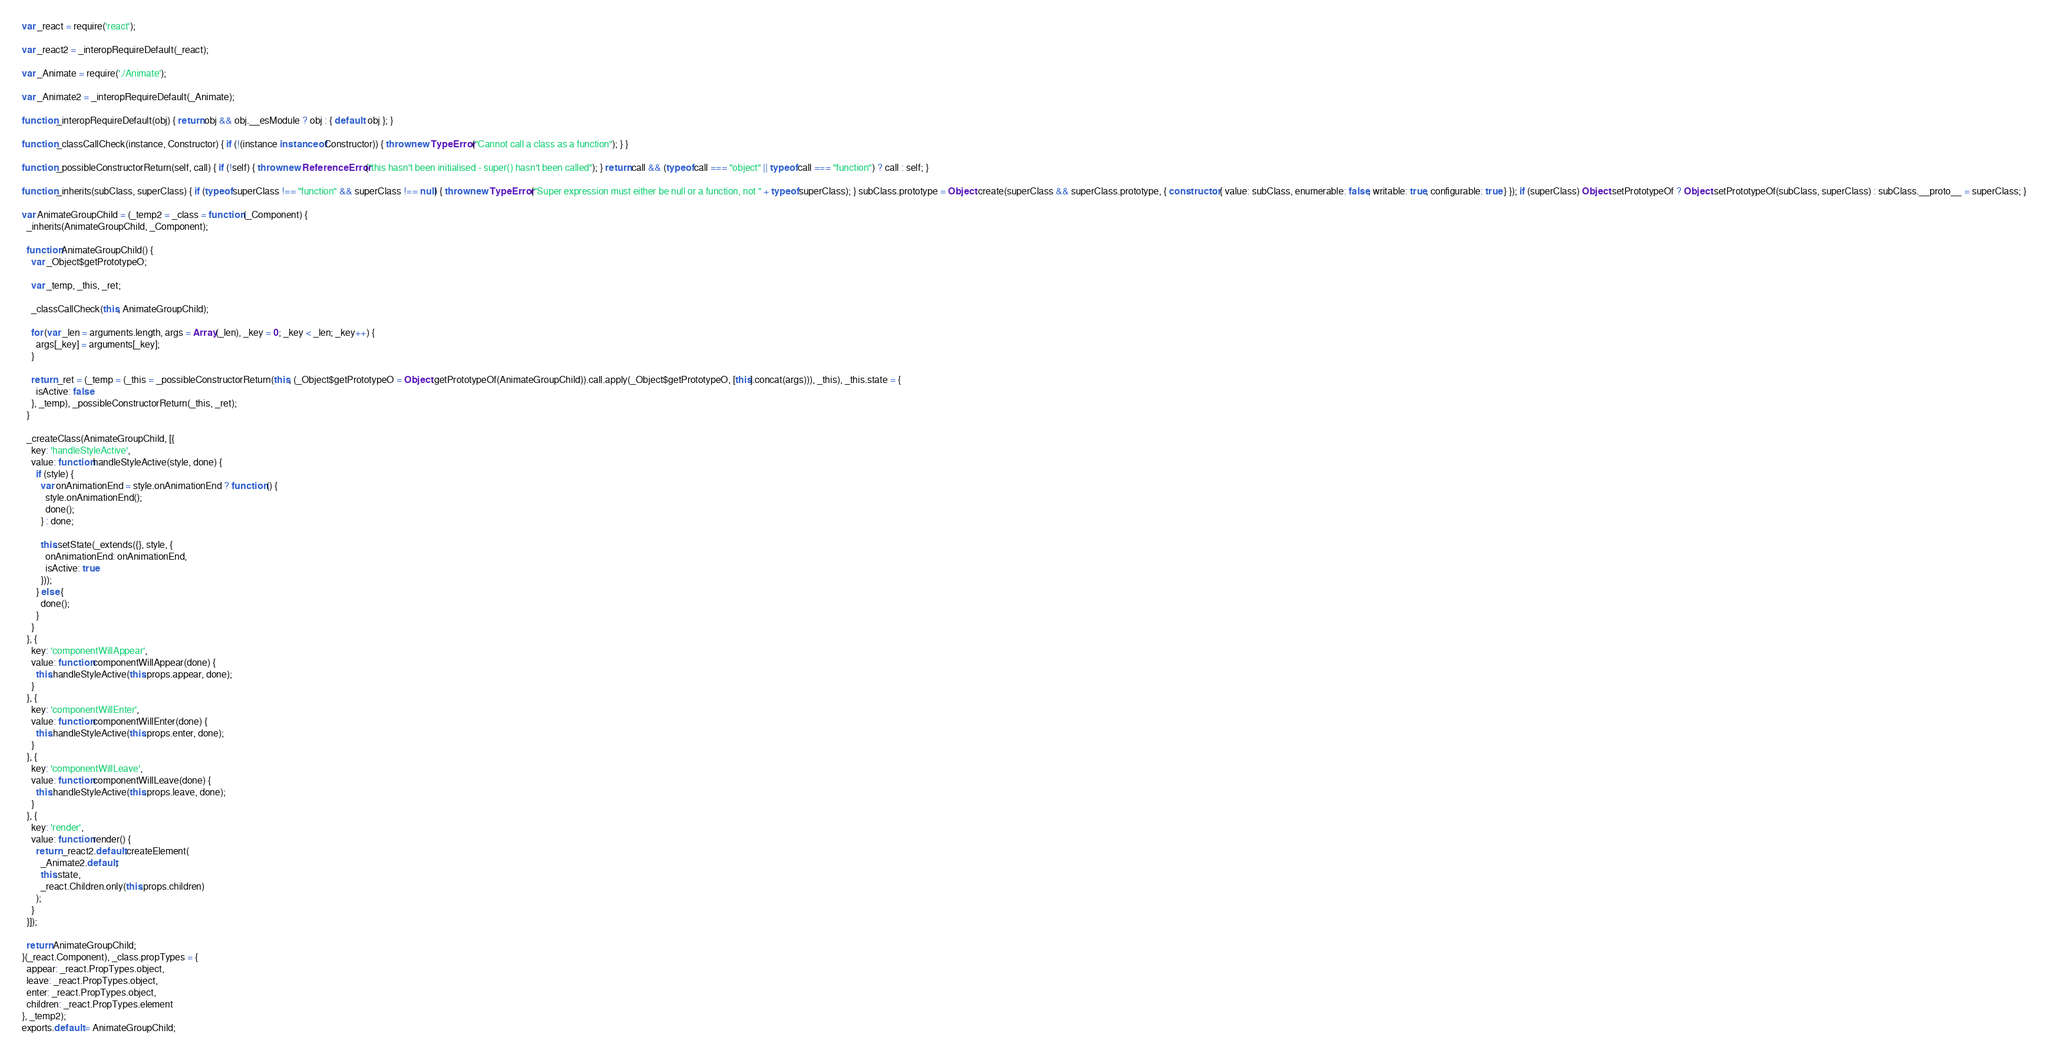<code> <loc_0><loc_0><loc_500><loc_500><_JavaScript_>var _react = require('react');

var _react2 = _interopRequireDefault(_react);

var _Animate = require('./Animate');

var _Animate2 = _interopRequireDefault(_Animate);

function _interopRequireDefault(obj) { return obj && obj.__esModule ? obj : { default: obj }; }

function _classCallCheck(instance, Constructor) { if (!(instance instanceof Constructor)) { throw new TypeError("Cannot call a class as a function"); } }

function _possibleConstructorReturn(self, call) { if (!self) { throw new ReferenceError("this hasn't been initialised - super() hasn't been called"); } return call && (typeof call === "object" || typeof call === "function") ? call : self; }

function _inherits(subClass, superClass) { if (typeof superClass !== "function" && superClass !== null) { throw new TypeError("Super expression must either be null or a function, not " + typeof superClass); } subClass.prototype = Object.create(superClass && superClass.prototype, { constructor: { value: subClass, enumerable: false, writable: true, configurable: true } }); if (superClass) Object.setPrototypeOf ? Object.setPrototypeOf(subClass, superClass) : subClass.__proto__ = superClass; }

var AnimateGroupChild = (_temp2 = _class = function (_Component) {
  _inherits(AnimateGroupChild, _Component);

  function AnimateGroupChild() {
    var _Object$getPrototypeO;

    var _temp, _this, _ret;

    _classCallCheck(this, AnimateGroupChild);

    for (var _len = arguments.length, args = Array(_len), _key = 0; _key < _len; _key++) {
      args[_key] = arguments[_key];
    }

    return _ret = (_temp = (_this = _possibleConstructorReturn(this, (_Object$getPrototypeO = Object.getPrototypeOf(AnimateGroupChild)).call.apply(_Object$getPrototypeO, [this].concat(args))), _this), _this.state = {
      isActive: false
    }, _temp), _possibleConstructorReturn(_this, _ret);
  }

  _createClass(AnimateGroupChild, [{
    key: 'handleStyleActive',
    value: function handleStyleActive(style, done) {
      if (style) {
        var onAnimationEnd = style.onAnimationEnd ? function () {
          style.onAnimationEnd();
          done();
        } : done;

        this.setState(_extends({}, style, {
          onAnimationEnd: onAnimationEnd,
          isActive: true
        }));
      } else {
        done();
      }
    }
  }, {
    key: 'componentWillAppear',
    value: function componentWillAppear(done) {
      this.handleStyleActive(this.props.appear, done);
    }
  }, {
    key: 'componentWillEnter',
    value: function componentWillEnter(done) {
      this.handleStyleActive(this.props.enter, done);
    }
  }, {
    key: 'componentWillLeave',
    value: function componentWillLeave(done) {
      this.handleStyleActive(this.props.leave, done);
    }
  }, {
    key: 'render',
    value: function render() {
      return _react2.default.createElement(
        _Animate2.default,
        this.state,
        _react.Children.only(this.props.children)
      );
    }
  }]);

  return AnimateGroupChild;
}(_react.Component), _class.propTypes = {
  appear: _react.PropTypes.object,
  leave: _react.PropTypes.object,
  enter: _react.PropTypes.object,
  children: _react.PropTypes.element
}, _temp2);
exports.default = AnimateGroupChild;</code> 